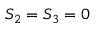Convert formula to latex. <formula><loc_0><loc_0><loc_500><loc_500>S _ { 2 } = S _ { 3 } = 0</formula> 